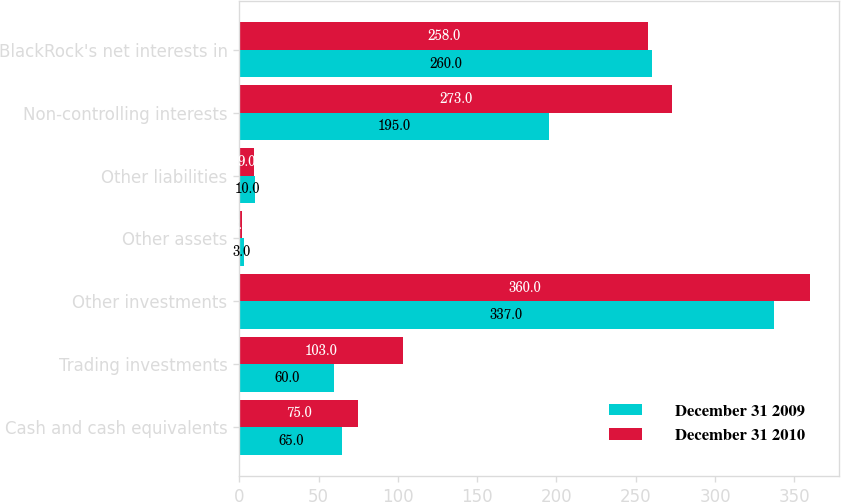Convert chart. <chart><loc_0><loc_0><loc_500><loc_500><stacked_bar_chart><ecel><fcel>Cash and cash equivalents<fcel>Trading investments<fcel>Other investments<fcel>Other assets<fcel>Other liabilities<fcel>Non-controlling interests<fcel>BlackRock's net interests in<nl><fcel>December 31 2009<fcel>65<fcel>60<fcel>337<fcel>3<fcel>10<fcel>195<fcel>260<nl><fcel>December 31 2010<fcel>75<fcel>103<fcel>360<fcel>2<fcel>9<fcel>273<fcel>258<nl></chart> 